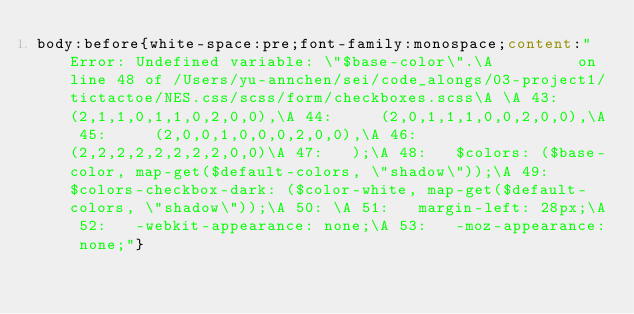Convert code to text. <code><loc_0><loc_0><loc_500><loc_500><_CSS_>body:before{white-space:pre;font-family:monospace;content:"Error: Undefined variable: \"$base-color\".\A         on line 48 of /Users/yu-annchen/sei/code_alongs/03-project1/tictactoe/NES.css/scss/form/checkboxes.scss\A \A 43:     (2,1,1,0,1,1,0,2,0,0),\A 44:     (2,0,1,1,1,0,0,2,0,0),\A 45:     (2,0,0,1,0,0,0,2,0,0),\A 46:     (2,2,2,2,2,2,2,2,0,0)\A 47:   );\A 48:   $colors: ($base-color, map-get($default-colors, \"shadow\"));\A 49:   $colors-checkbox-dark: ($color-white, map-get($default-colors, \"shadow\"));\A 50: \A 51:   margin-left: 28px;\A 52:   -webkit-appearance: none;\A 53:   -moz-appearance: none;"}</code> 